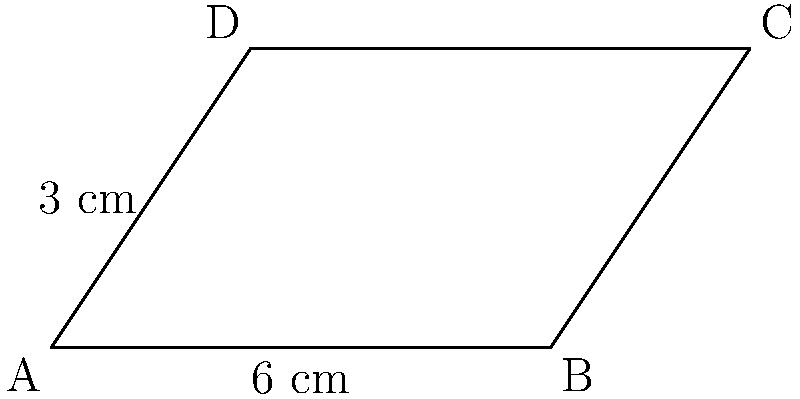While exploring the geometric patterns in Lima's architecture, you come across a parallelogram-shaped decorative tile. If the base of this parallelogram is 6 cm and its height is 3 cm, what is the area of the tile? To calculate the area of a parallelogram, we follow these steps:

1. Recall the formula for the area of a parallelogram:
   Area = base $\times$ height

2. Identify the given values:
   Base (b) = 6 cm
   Height (h) = 3 cm

3. Substitute these values into the formula:
   Area = 6 cm $\times$ 3 cm

4. Perform the multiplication:
   Area = 18 cm²

Therefore, the area of the parallelogram-shaped tile is 18 square centimeters.
Answer: 18 cm² 